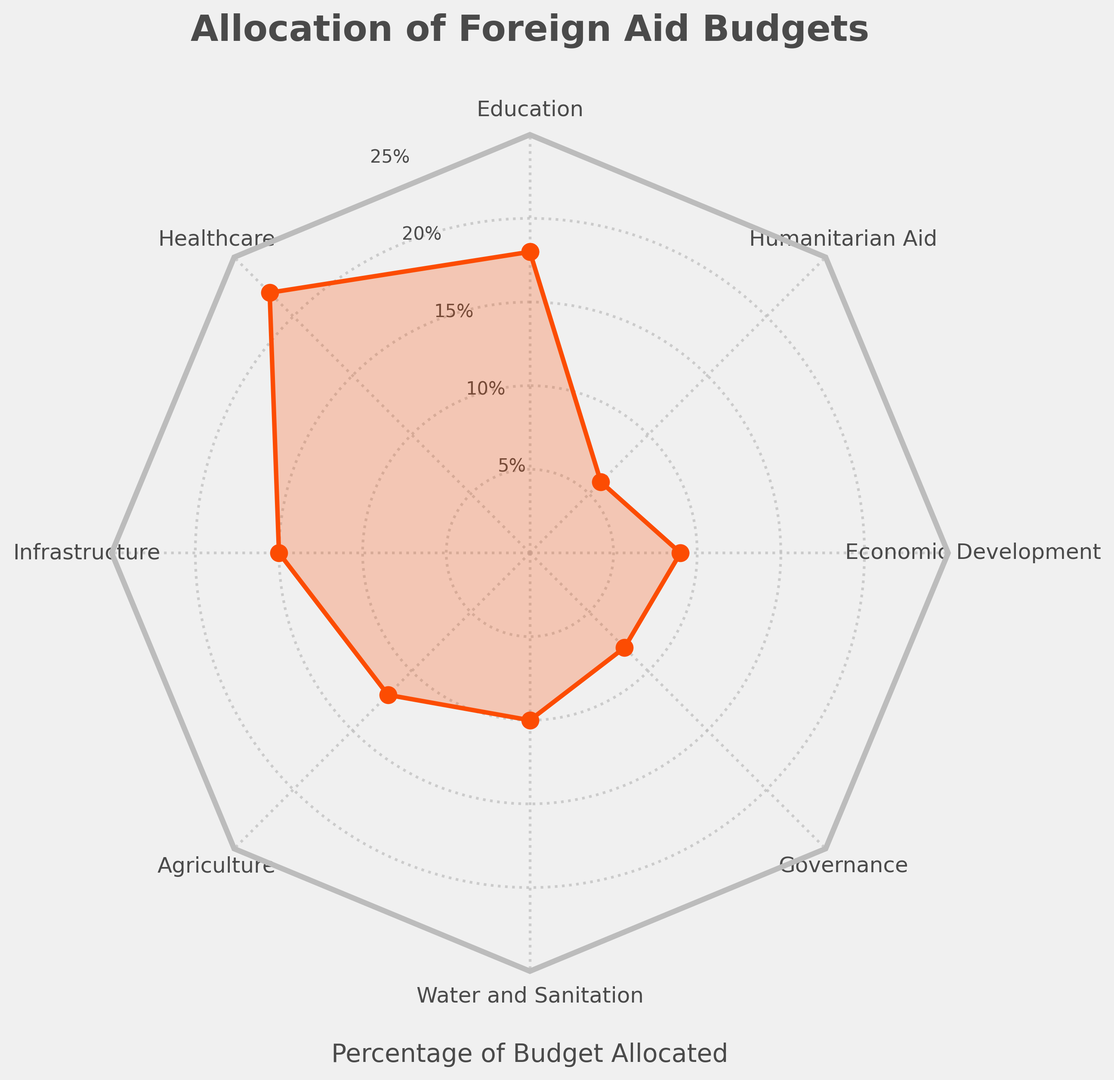Which sector receives the highest percentage of the foreign aid budget? Inspect the radar chart to determine the sector with the highest point on the radial axis. Healthcare is the tallest mark on the plot, indicating it has the highest percentage allocation.
Answer: Healthcare Compare the budget allocations for Education and Economic Development. Which sector receives a higher percentage? Look at the points for Education and Economic Development on the radial axes. Education's point is at 18%, whereas Economic Development is at 9%.
Answer: Education What is the combined percentage of foreign aid allocated to Governance and Humanitarian Aid? Find the percentages for Governance and Humanitarian Aid. Governance is 8% and Humanitarian Aid is 6%, add these two values: 8% + 6% = 14%.
Answer: 14% Which sector has the smallest allocation, and what is its percentage? Identify the shortest point in the radar chart. The smallest allocation is for Humanitarian Aid, which is 6%.
Answer: Humanitarian Aid, 6% What is the average percentage allocation for Infrastructure, Agriculture, and Water and Sanitation? Find the percentages for Infrastructure (15%), Agriculture (12%), and Water and Sanitation (10%). Calculate the average: (15% + 12% + 10%) / 3 = 12.33%.
Answer: 12.33% How much more percentage is allocated to Healthcare compared to Education? Look at the percentage allocations for Healthcare (22%) and Education (18%). Subtract the percentage for Education from Healthcare: 22% - 18% = 4%.
Answer: 4% Are there any sectors that receive equal percentage allocations? If so, which ones? Examine the radar chart for sectors with overlapping points on the radial axes. No two points overlap, indicating no equal allocations.
Answer: No Compare the allocation percentages for Agriculture and Governance in terms of relative percentages. Which sector has a higher percentage, and by how much? Observe the points for Agriculture (12%) and Governance (8%). Subtract Governance's percentage from Agriculture's: 12% - 8% = 4%. Agriculture has a higher percentage by 4%.
Answer: Agriculture, 4% What sectors have an allocation percentage greater than 15%? Look at the radial points that lie above the 15% mark. Education (18%) and Healthcare (22%) are both above 15%.
Answer: Education and Healthcare What is the median percentage of all the budget allocations? List all percentages: 18, 22, 15, 12, 10, 8, 9, 6. Order them: 6, 8, 9, 10, 12, 15, 18, 22. The median is the middle value in this ordered list. For 8 values, the median is (10 + 12) / 2 = 11%.
Answer: 11% 